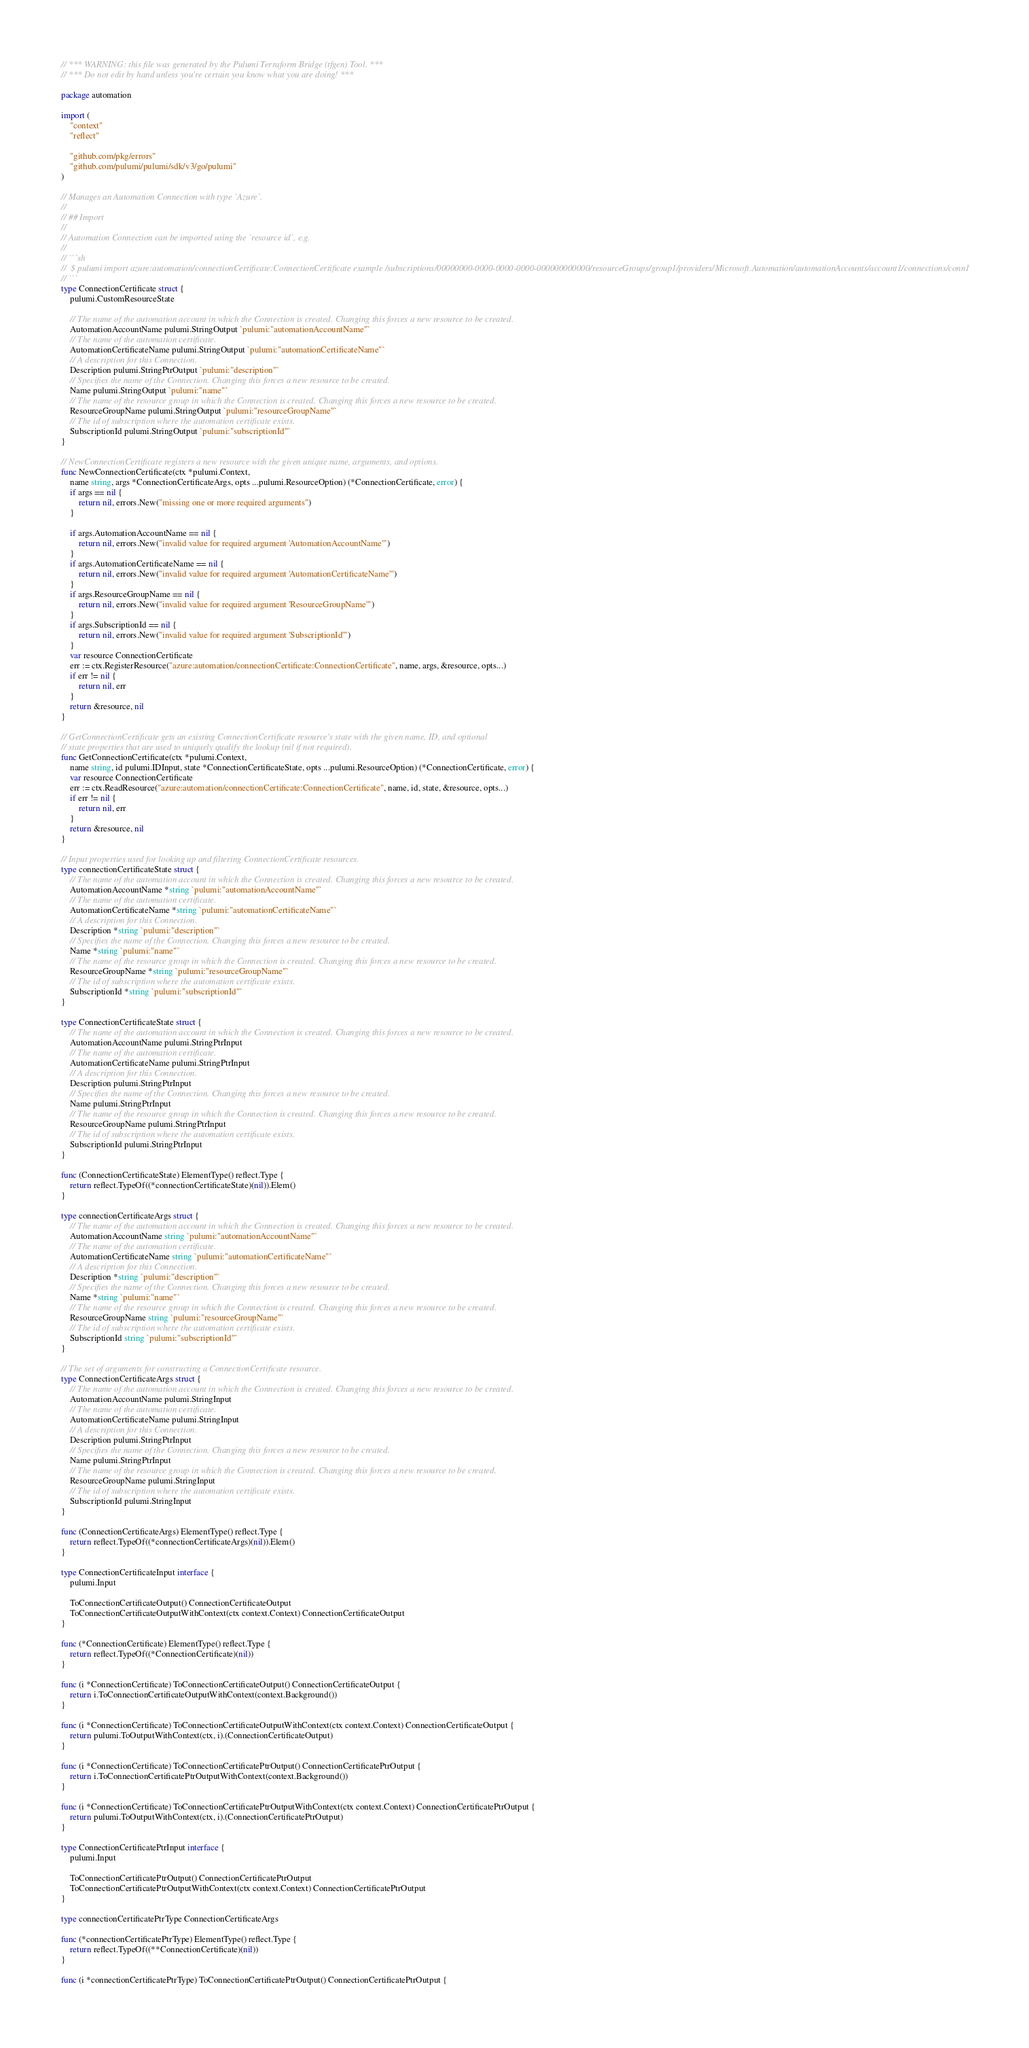<code> <loc_0><loc_0><loc_500><loc_500><_Go_>// *** WARNING: this file was generated by the Pulumi Terraform Bridge (tfgen) Tool. ***
// *** Do not edit by hand unless you're certain you know what you are doing! ***

package automation

import (
	"context"
	"reflect"

	"github.com/pkg/errors"
	"github.com/pulumi/pulumi/sdk/v3/go/pulumi"
)

// Manages an Automation Connection with type `Azure`.
//
// ## Import
//
// Automation Connection can be imported using the `resource id`, e.g.
//
// ```sh
//  $ pulumi import azure:automation/connectionCertificate:ConnectionCertificate example /subscriptions/00000000-0000-0000-0000-000000000000/resourceGroups/group1/providers/Microsoft.Automation/automationAccounts/account1/connections/conn1
// ```
type ConnectionCertificate struct {
	pulumi.CustomResourceState

	// The name of the automation account in which the Connection is created. Changing this forces a new resource to be created.
	AutomationAccountName pulumi.StringOutput `pulumi:"automationAccountName"`
	// The name of the automation certificate.
	AutomationCertificateName pulumi.StringOutput `pulumi:"automationCertificateName"`
	// A description for this Connection.
	Description pulumi.StringPtrOutput `pulumi:"description"`
	// Specifies the name of the Connection. Changing this forces a new resource to be created.
	Name pulumi.StringOutput `pulumi:"name"`
	// The name of the resource group in which the Connection is created. Changing this forces a new resource to be created.
	ResourceGroupName pulumi.StringOutput `pulumi:"resourceGroupName"`
	// The id of subscription where the automation certificate exists.
	SubscriptionId pulumi.StringOutput `pulumi:"subscriptionId"`
}

// NewConnectionCertificate registers a new resource with the given unique name, arguments, and options.
func NewConnectionCertificate(ctx *pulumi.Context,
	name string, args *ConnectionCertificateArgs, opts ...pulumi.ResourceOption) (*ConnectionCertificate, error) {
	if args == nil {
		return nil, errors.New("missing one or more required arguments")
	}

	if args.AutomationAccountName == nil {
		return nil, errors.New("invalid value for required argument 'AutomationAccountName'")
	}
	if args.AutomationCertificateName == nil {
		return nil, errors.New("invalid value for required argument 'AutomationCertificateName'")
	}
	if args.ResourceGroupName == nil {
		return nil, errors.New("invalid value for required argument 'ResourceGroupName'")
	}
	if args.SubscriptionId == nil {
		return nil, errors.New("invalid value for required argument 'SubscriptionId'")
	}
	var resource ConnectionCertificate
	err := ctx.RegisterResource("azure:automation/connectionCertificate:ConnectionCertificate", name, args, &resource, opts...)
	if err != nil {
		return nil, err
	}
	return &resource, nil
}

// GetConnectionCertificate gets an existing ConnectionCertificate resource's state with the given name, ID, and optional
// state properties that are used to uniquely qualify the lookup (nil if not required).
func GetConnectionCertificate(ctx *pulumi.Context,
	name string, id pulumi.IDInput, state *ConnectionCertificateState, opts ...pulumi.ResourceOption) (*ConnectionCertificate, error) {
	var resource ConnectionCertificate
	err := ctx.ReadResource("azure:automation/connectionCertificate:ConnectionCertificate", name, id, state, &resource, opts...)
	if err != nil {
		return nil, err
	}
	return &resource, nil
}

// Input properties used for looking up and filtering ConnectionCertificate resources.
type connectionCertificateState struct {
	// The name of the automation account in which the Connection is created. Changing this forces a new resource to be created.
	AutomationAccountName *string `pulumi:"automationAccountName"`
	// The name of the automation certificate.
	AutomationCertificateName *string `pulumi:"automationCertificateName"`
	// A description for this Connection.
	Description *string `pulumi:"description"`
	// Specifies the name of the Connection. Changing this forces a new resource to be created.
	Name *string `pulumi:"name"`
	// The name of the resource group in which the Connection is created. Changing this forces a new resource to be created.
	ResourceGroupName *string `pulumi:"resourceGroupName"`
	// The id of subscription where the automation certificate exists.
	SubscriptionId *string `pulumi:"subscriptionId"`
}

type ConnectionCertificateState struct {
	// The name of the automation account in which the Connection is created. Changing this forces a new resource to be created.
	AutomationAccountName pulumi.StringPtrInput
	// The name of the automation certificate.
	AutomationCertificateName pulumi.StringPtrInput
	// A description for this Connection.
	Description pulumi.StringPtrInput
	// Specifies the name of the Connection. Changing this forces a new resource to be created.
	Name pulumi.StringPtrInput
	// The name of the resource group in which the Connection is created. Changing this forces a new resource to be created.
	ResourceGroupName pulumi.StringPtrInput
	// The id of subscription where the automation certificate exists.
	SubscriptionId pulumi.StringPtrInput
}

func (ConnectionCertificateState) ElementType() reflect.Type {
	return reflect.TypeOf((*connectionCertificateState)(nil)).Elem()
}

type connectionCertificateArgs struct {
	// The name of the automation account in which the Connection is created. Changing this forces a new resource to be created.
	AutomationAccountName string `pulumi:"automationAccountName"`
	// The name of the automation certificate.
	AutomationCertificateName string `pulumi:"automationCertificateName"`
	// A description for this Connection.
	Description *string `pulumi:"description"`
	// Specifies the name of the Connection. Changing this forces a new resource to be created.
	Name *string `pulumi:"name"`
	// The name of the resource group in which the Connection is created. Changing this forces a new resource to be created.
	ResourceGroupName string `pulumi:"resourceGroupName"`
	// The id of subscription where the automation certificate exists.
	SubscriptionId string `pulumi:"subscriptionId"`
}

// The set of arguments for constructing a ConnectionCertificate resource.
type ConnectionCertificateArgs struct {
	// The name of the automation account in which the Connection is created. Changing this forces a new resource to be created.
	AutomationAccountName pulumi.StringInput
	// The name of the automation certificate.
	AutomationCertificateName pulumi.StringInput
	// A description for this Connection.
	Description pulumi.StringPtrInput
	// Specifies the name of the Connection. Changing this forces a new resource to be created.
	Name pulumi.StringPtrInput
	// The name of the resource group in which the Connection is created. Changing this forces a new resource to be created.
	ResourceGroupName pulumi.StringInput
	// The id of subscription where the automation certificate exists.
	SubscriptionId pulumi.StringInput
}

func (ConnectionCertificateArgs) ElementType() reflect.Type {
	return reflect.TypeOf((*connectionCertificateArgs)(nil)).Elem()
}

type ConnectionCertificateInput interface {
	pulumi.Input

	ToConnectionCertificateOutput() ConnectionCertificateOutput
	ToConnectionCertificateOutputWithContext(ctx context.Context) ConnectionCertificateOutput
}

func (*ConnectionCertificate) ElementType() reflect.Type {
	return reflect.TypeOf((*ConnectionCertificate)(nil))
}

func (i *ConnectionCertificate) ToConnectionCertificateOutput() ConnectionCertificateOutput {
	return i.ToConnectionCertificateOutputWithContext(context.Background())
}

func (i *ConnectionCertificate) ToConnectionCertificateOutputWithContext(ctx context.Context) ConnectionCertificateOutput {
	return pulumi.ToOutputWithContext(ctx, i).(ConnectionCertificateOutput)
}

func (i *ConnectionCertificate) ToConnectionCertificatePtrOutput() ConnectionCertificatePtrOutput {
	return i.ToConnectionCertificatePtrOutputWithContext(context.Background())
}

func (i *ConnectionCertificate) ToConnectionCertificatePtrOutputWithContext(ctx context.Context) ConnectionCertificatePtrOutput {
	return pulumi.ToOutputWithContext(ctx, i).(ConnectionCertificatePtrOutput)
}

type ConnectionCertificatePtrInput interface {
	pulumi.Input

	ToConnectionCertificatePtrOutput() ConnectionCertificatePtrOutput
	ToConnectionCertificatePtrOutputWithContext(ctx context.Context) ConnectionCertificatePtrOutput
}

type connectionCertificatePtrType ConnectionCertificateArgs

func (*connectionCertificatePtrType) ElementType() reflect.Type {
	return reflect.TypeOf((**ConnectionCertificate)(nil))
}

func (i *connectionCertificatePtrType) ToConnectionCertificatePtrOutput() ConnectionCertificatePtrOutput {</code> 